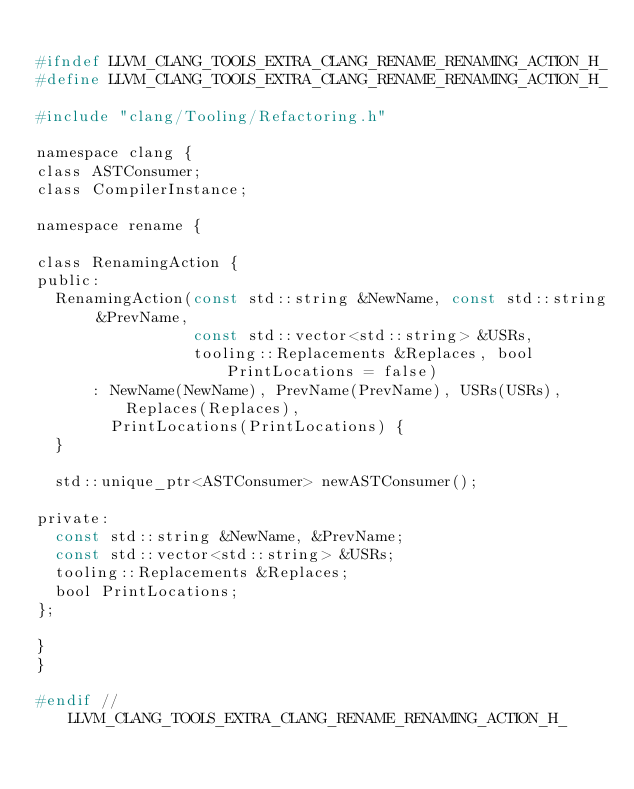Convert code to text. <code><loc_0><loc_0><loc_500><loc_500><_C_>
#ifndef LLVM_CLANG_TOOLS_EXTRA_CLANG_RENAME_RENAMING_ACTION_H_
#define LLVM_CLANG_TOOLS_EXTRA_CLANG_RENAME_RENAMING_ACTION_H_

#include "clang/Tooling/Refactoring.h"

namespace clang {
class ASTConsumer;
class CompilerInstance;

namespace rename {

class RenamingAction {
public:
  RenamingAction(const std::string &NewName, const std::string &PrevName,
                 const std::vector<std::string> &USRs,
                 tooling::Replacements &Replaces, bool PrintLocations = false)
      : NewName(NewName), PrevName(PrevName), USRs(USRs), Replaces(Replaces),
        PrintLocations(PrintLocations) {
  }

  std::unique_ptr<ASTConsumer> newASTConsumer();

private:
  const std::string &NewName, &PrevName;
  const std::vector<std::string> &USRs;
  tooling::Replacements &Replaces;
  bool PrintLocations;
};

}
}

#endif // LLVM_CLANG_TOOLS_EXTRA_CLANG_RENAME_RENAMING_ACTION_H_
</code> 